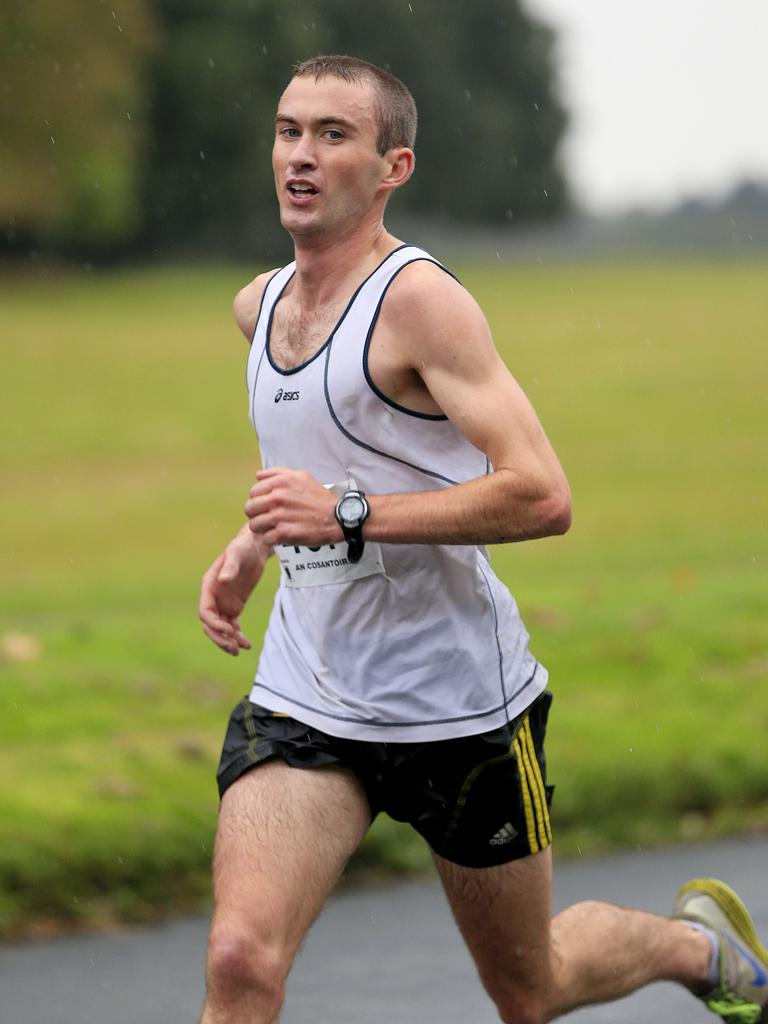Provide a one-sentence caption for the provided image. a man running with the word Adidas on his shorts. 